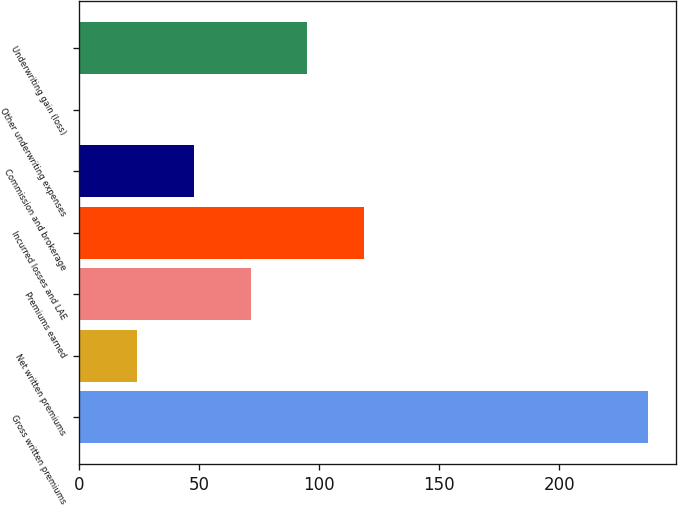<chart> <loc_0><loc_0><loc_500><loc_500><bar_chart><fcel>Gross written premiums<fcel>Net written premiums<fcel>Premiums earned<fcel>Incurred losses and LAE<fcel>Commission and brokerage<fcel>Other underwriting expenses<fcel>Underwriting gain (loss)<nl><fcel>236.7<fcel>24.3<fcel>71.5<fcel>118.7<fcel>47.9<fcel>0.7<fcel>95.1<nl></chart> 